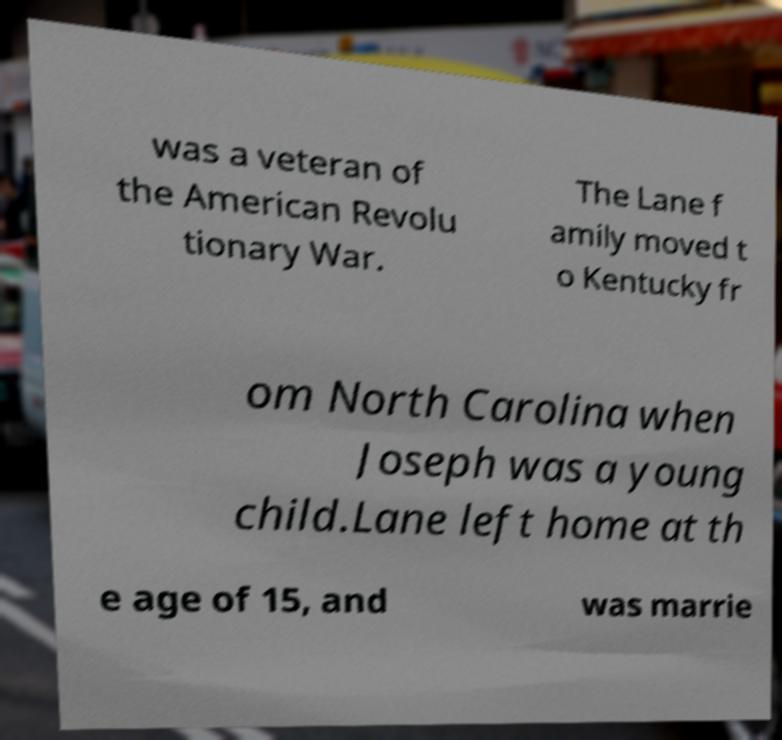What messages or text are displayed in this image? I need them in a readable, typed format. was a veteran of the American Revolu tionary War. The Lane f amily moved t o Kentucky fr om North Carolina when Joseph was a young child.Lane left home at th e age of 15, and was marrie 